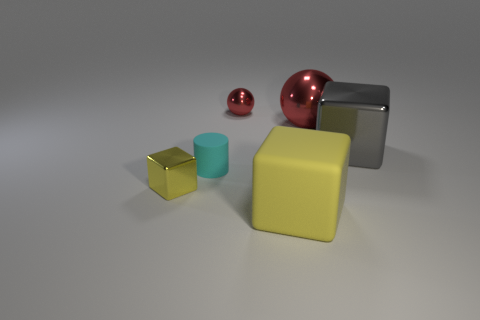Add 3 big red spheres. How many objects exist? 9 Subtract all spheres. How many objects are left? 4 Add 6 small green shiny objects. How many small green shiny objects exist? 6 Subtract 0 blue spheres. How many objects are left? 6 Subtract all gray metallic things. Subtract all big spheres. How many objects are left? 4 Add 6 gray metallic cubes. How many gray metallic cubes are left? 7 